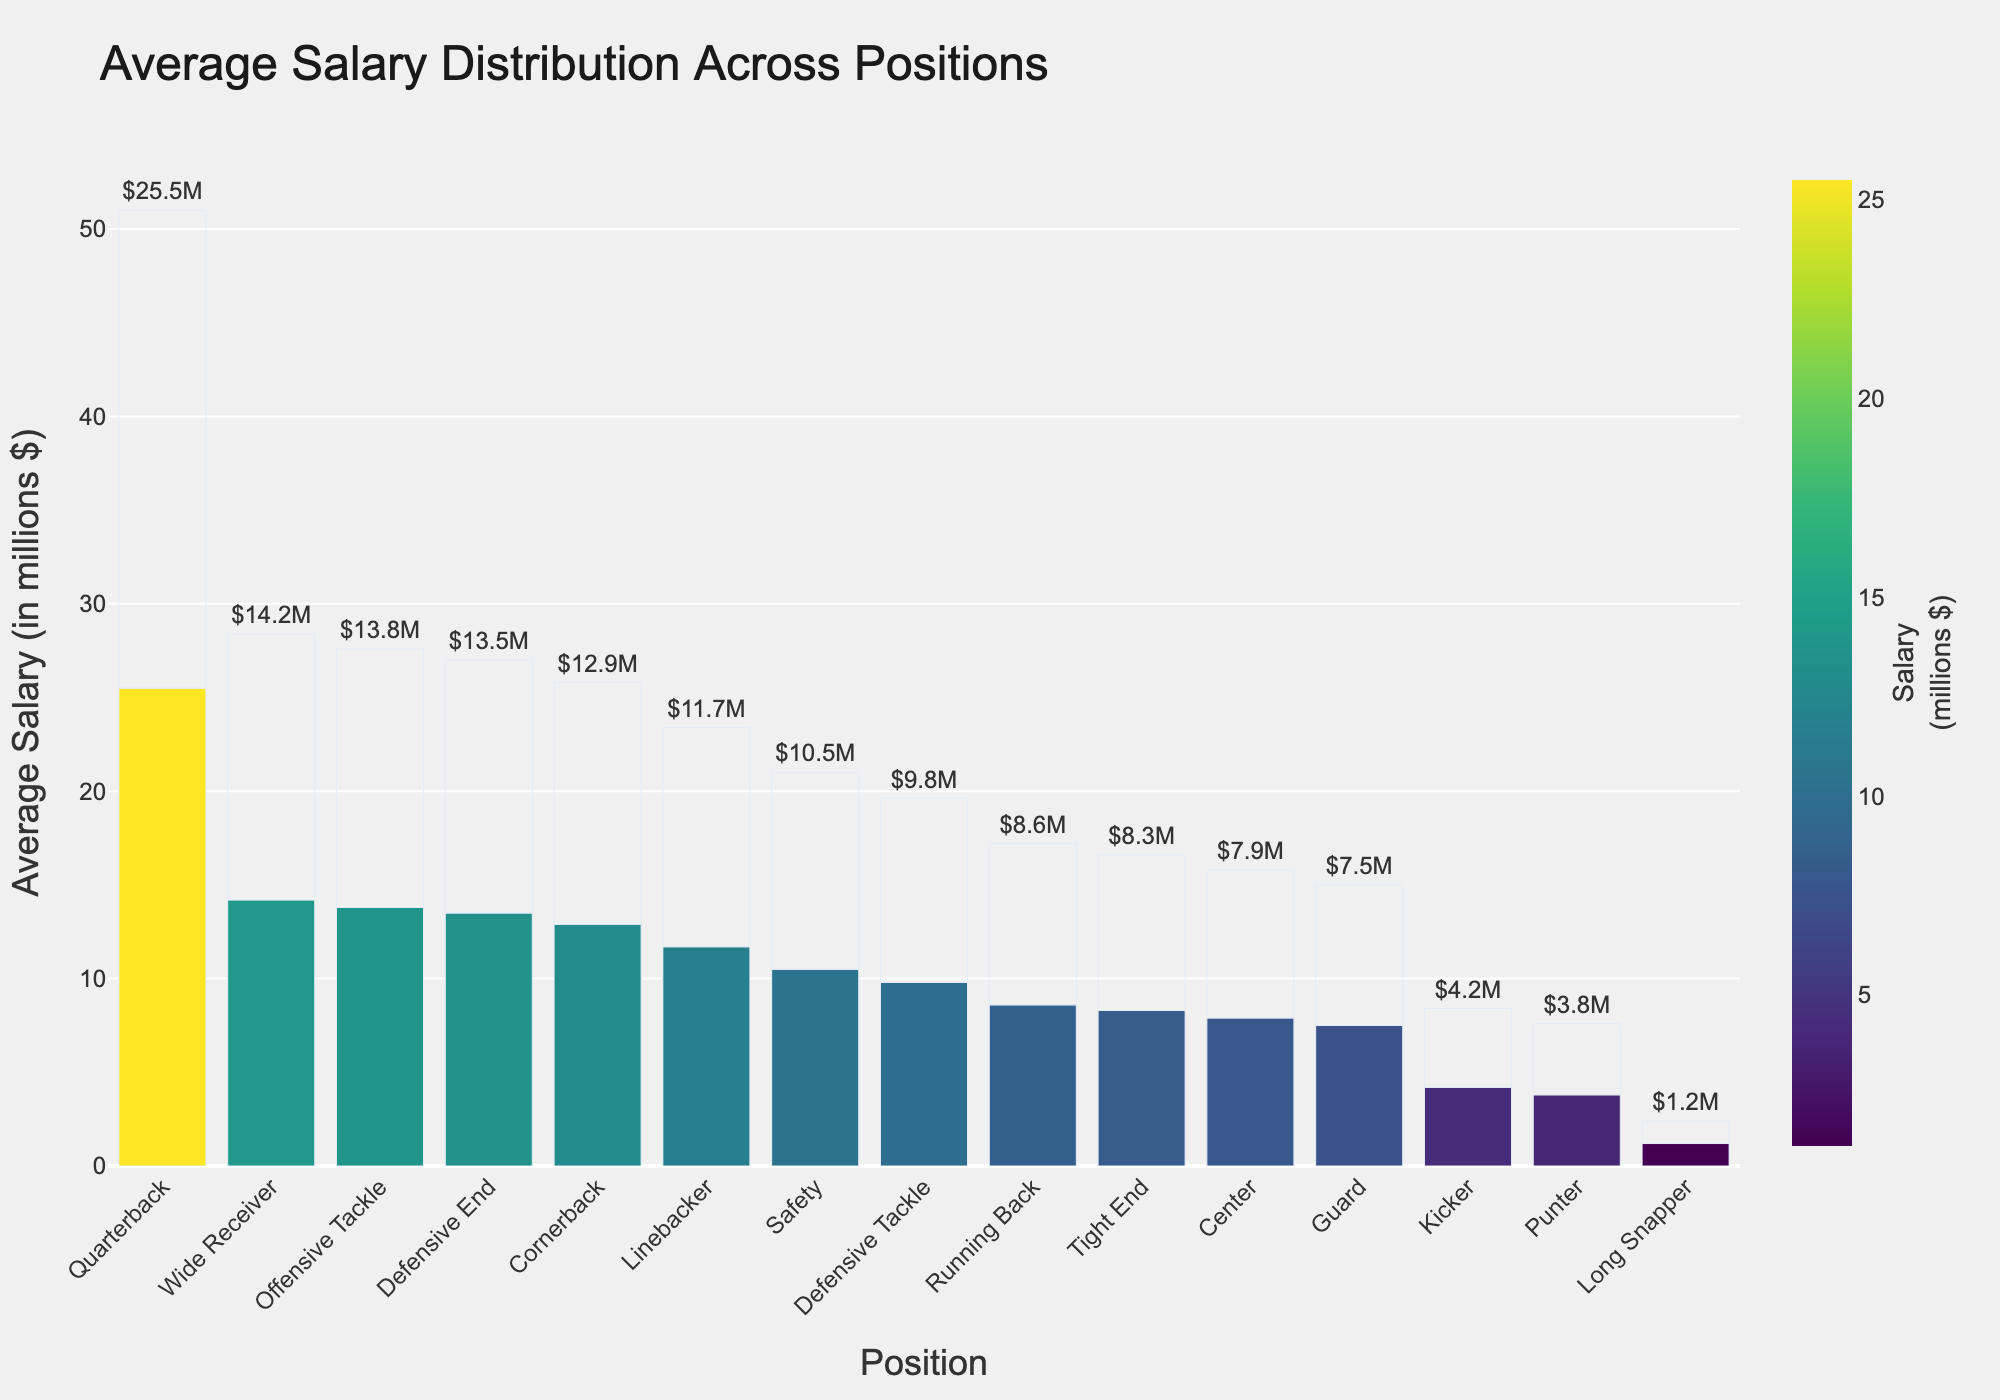Which position has the highest average salary? By observing the bar height and color in the bar chart, the position with the highest average salary corresponds to the tallest bar with the darkest color. The "Quarterback" position has the highest average salary.
Answer: Quarterback How much more does an Offensive Tackle earn on average compared to a Linebacker? To find out, locate the bars for Offensive Tackle and Linebacker. The Offensive Tackle's average salary is 13.8 million, and the Linebacker's average salary is 11.7 million. Subtract the Linebacker's salary from the Offensive Tackle's. 13.8 - 11.7 = 2.1 million.
Answer: 2.1 million What is the combined average salary of a Quarterback, Wide Receiver, and Tight End? Locate the bars for Quarterback, Wide Receiver, and Tight End. Their average salaries are 25.5, 14.2, and 8.3 million respectively. Sum these values. 25.5 + 14.2 + 8.3 = 48 million.
Answer: 48 million Which position earns less on average than a Safety but more than a Kicker? Locate the bars for Safety and Kicker first. Safety earns 10.5 million, and Kicker earns 4.2 million. Identify the bars in between these two values. The "Running Back" and "Tight End" bars fit this criterion, with Running Back earning 8.6 million and Tight End earning 8.3 million.
Answer: Running Back and Tight End Is the average salary of a Wide Receiver greater than twice the average salary of a Guard? First, find the average salaries for Wide Receiver and Guard, which are 14.2 million and 7.5 million respectively. Compute twice the Guard's salary, which is 7.5 * 2 = 15 million. Check if Wide Receiver's salary (14.2 million) is greater than 15 million. It isn't.
Answer: No, it is not Rank the top five positions by their average salary. Order the bars from tallest to shortest. The top five positions in order are: Quarterback (25.5 million), Wide Receiver (14.2 million), Offensive Tackle (13.8 million), Defensive End (13.5 million), and Cornerback (12.9 million).
Answer: Quarterback, Wide Receiver, Offensive Tackle, Defensive End, Cornerback What is the salary range between the highest and lowest-paid positions? The highest-paid position is Quarterback with 25.5 million, and the lowest-paid position is Long Snapper with 1.2 million. Subtract the lowest from the highest. 25.5 - 1.2 = 24.3 million.
Answer: 24.3 million What is the visual difference in color intensity between the highest and lowest-paid positions? The bar for the highest-paid position (Quarterback) will have the darkest color, and the bar for the lowest-paid position (Long Snapper) will have the lightest color. There's a clear gradient from dark to light, indicating a large difference in salary.
Answer: Darkest to lightest How many positions have an average salary greater than 10 million? Count the number of bars with heights indicating salaries greater than 10 million. These positions are Quarterback, Wide Receiver, Offensive Tackle, Defensive End, Cornerback, and Linebacker. There are six positions.
Answer: Six If the average salary of Defensive Tackle increases by 2 million, will it surpass the salary of Safety? The current average salary for Defensive Tackle is 9.8 million. If it increases by 2 million (9.8 + 2 = 11.8 million), compare this to the average salary of Safety, which is 10.5 million. 11.8 million is indeed greater than 10.5 million.
Answer: Yes 